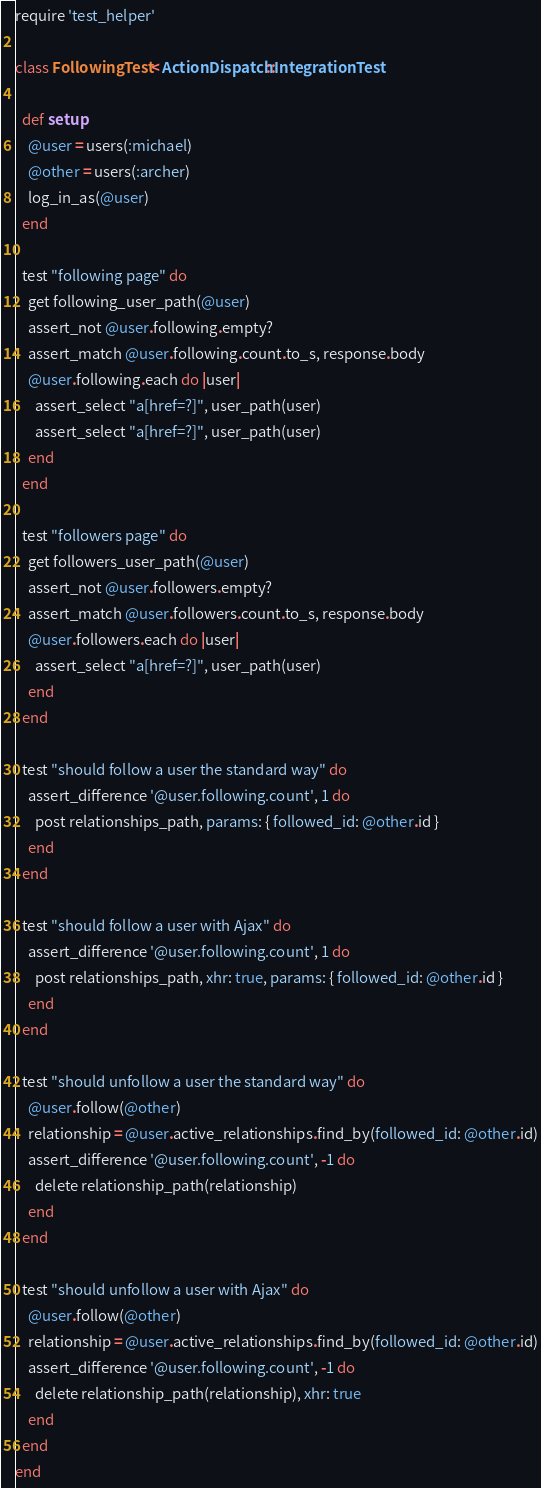<code> <loc_0><loc_0><loc_500><loc_500><_Ruby_>require 'test_helper'

class FollowingTest < ActionDispatch::IntegrationTest
 
  def setup
    @user = users(:michael)
    @other = users(:archer)
    log_in_as(@user)
  end

  test "following page" do
    get following_user_path(@user)
    assert_not @user.following.empty?
    assert_match @user.following.count.to_s, response.body
    @user.following.each do |user|
      assert_select "a[href=?]", user_path(user)
      assert_select "a[href=?]", user_path(user)
    end
  end

  test "followers page" do
    get followers_user_path(@user)
    assert_not @user.followers.empty?
    assert_match @user.followers.count.to_s, response.body
    @user.followers.each do |user|
      assert_select "a[href=?]", user_path(user)
    end
  end
  
  test "should follow a user the standard way" do
    assert_difference '@user.following.count', 1 do
      post relationships_path, params: { followed_id: @other.id }
    end
  end

  test "should follow a user with Ajax" do
    assert_difference '@user.following.count', 1 do
      post relationships_path, xhr: true, params: { followed_id: @other.id }
    end
  end

  test "should unfollow a user the standard way" do
    @user.follow(@other)
    relationship = @user.active_relationships.find_by(followed_id: @other.id)
    assert_difference '@user.following.count', -1 do
      delete relationship_path(relationship)
    end
  end

  test "should unfollow a user with Ajax" do
    @user.follow(@other)
    relationship = @user.active_relationships.find_by(followed_id: @other.id)
    assert_difference '@user.following.count', -1 do
      delete relationship_path(relationship), xhr: true
    end
  end
end
</code> 